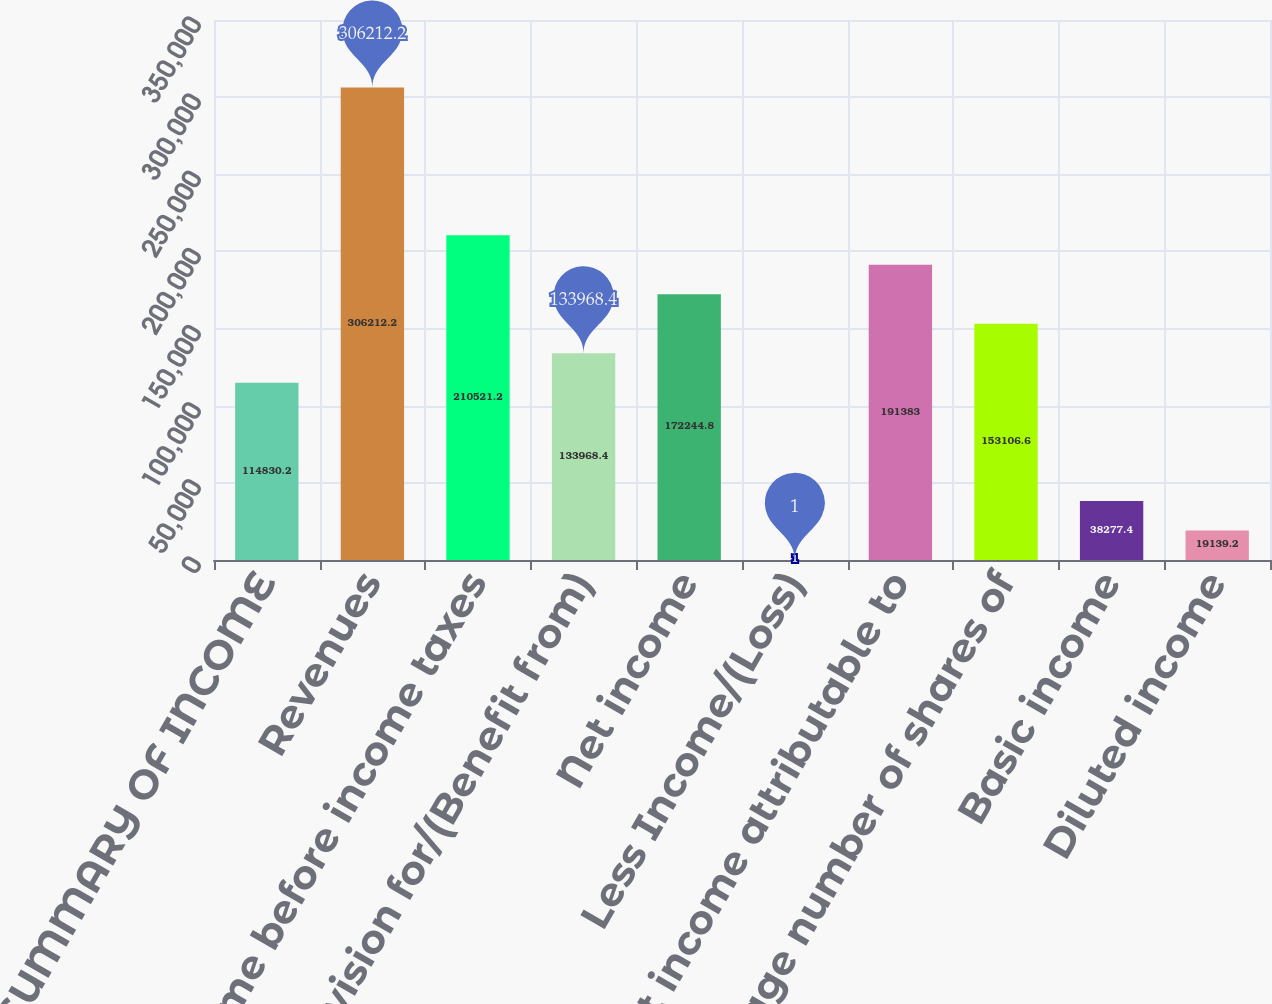<chart> <loc_0><loc_0><loc_500><loc_500><bar_chart><fcel>SUMMARY OF INCOME<fcel>Revenues<fcel>Income before income taxes<fcel>Provision for/(Benefit from)<fcel>Net income<fcel>Less Income/(Loss)<fcel>Net income attributable to<fcel>Average number of shares of<fcel>Basic income<fcel>Diluted income<nl><fcel>114830<fcel>306212<fcel>210521<fcel>133968<fcel>172245<fcel>1<fcel>191383<fcel>153107<fcel>38277.4<fcel>19139.2<nl></chart> 